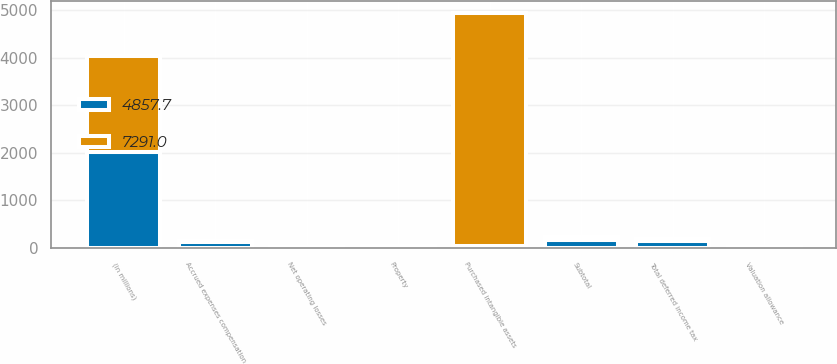<chart> <loc_0><loc_0><loc_500><loc_500><stacked_bar_chart><ecel><fcel>(in millions)<fcel>Net operating losses<fcel>Property<fcel>Accrued expenses compensation<fcel>Subtotal<fcel>Valuation allowance<fcel>Total deferred income tax<fcel>Purchased intangible assets<nl><fcel>7291<fcel>2017<fcel>13<fcel>5.5<fcel>37.2<fcel>55.7<fcel>11.2<fcel>44.5<fcel>4902.2<nl><fcel>4857.7<fcel>2016<fcel>18.8<fcel>31.4<fcel>119<fcel>169.2<fcel>14.9<fcel>154.3<fcel>44.5<nl></chart> 